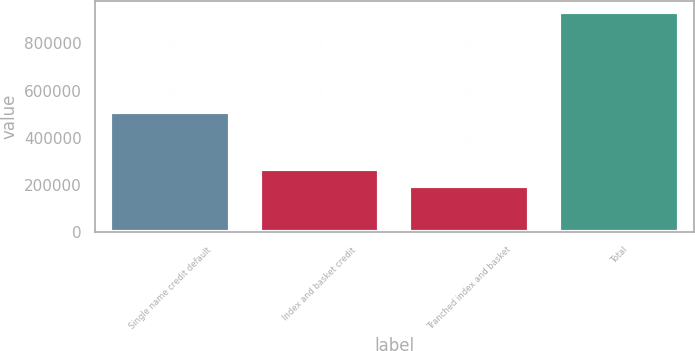<chart> <loc_0><loc_0><loc_500><loc_500><bar_chart><fcel>Single name credit default<fcel>Index and basket credit<fcel>Tranched index and basket<fcel>Total<nl><fcel>509872<fcel>268309<fcel>194343<fcel>934004<nl></chart> 